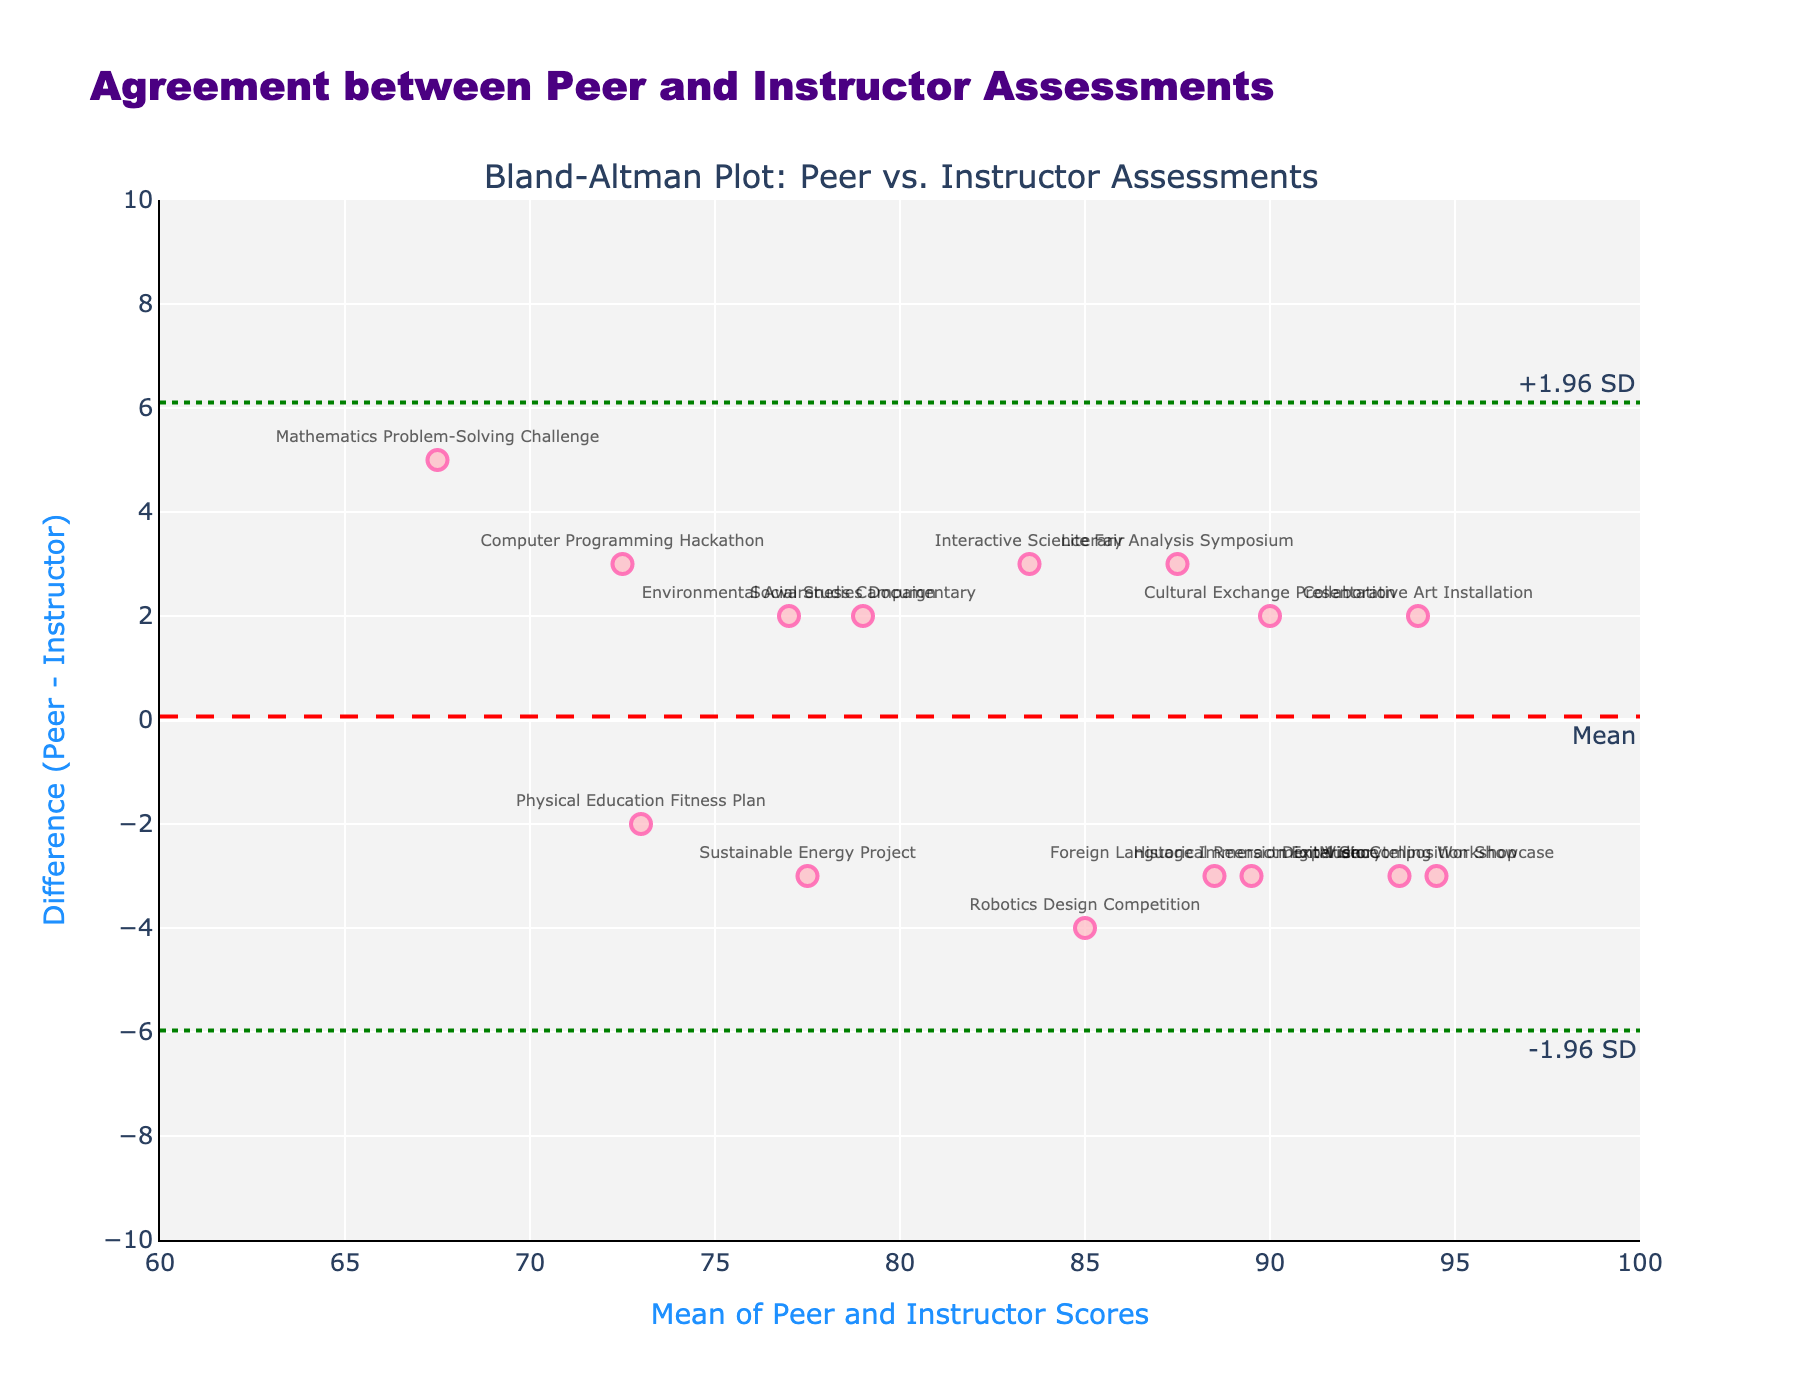What does the title of the plot tell us? The title "Agreement between Peer and Instructor Assessments" indicates that the plot is analyzing the level of agreement between scores given by peers and those given by instructors for group project evaluations.
Answer: Agreement between Peer and Instructor Assessments How many data points are represented in the plot? Each project has a corresponding data point in the plot. Since the dataset lists 15 projects, there are 15 data points.
Answer: 15 What are the units on the x-axis and y-axis, and what do they represent? The x-axis represents the mean of the Peer and Instructor Scores, ranging from 60 to 100 with ticks at every 5-unit interval. The y-axis represents the difference between the Peer and Instructor Scores (Peer - Instructor), ranging from -10 to 10 with ticks at every 2-unit interval.
Answer: x-axis units: Mean of Scores (60-100), y-axis units: Difference (-10 to 10) What is the mean difference between peer and instructor scores, and how is it visually represented on the plot? The mean difference is represented by a red dashed line on the plot. It indicates the average of the differences between peer and instructor scores.
Answer: Red dashed line Identify the project associated with the highest positive difference between peer and instructor scores. The project "Mathematics Problem-Solving Challenge" shows the highest positive difference on the plot, indicating peers scored it higher than the instructor.
Answer: Mathematics Problem-Solving Challenge Which projects fall outside the limits of agreement (±1.96 SD)? Projects that lie outside the green dotted lines on the plot fall outside the limits of agreement. Observing the plot, "Mathematics Problem-Solving Challenge" and "Collaborative Art Installation" exceed the limits.
Answer: Mathematics Problem-Solving Challenge, Collaborative Art Installation Calculate the mean score for the project "Music Composition Showcase" based on the x-axis. Using the x-axis mean of Peer and Instructor Scores for "Music Composition Showcase" (94.5), and knowing Peer was 93 and Instructor was 96, the mean is (93+96)/2.
Answer: 94.5 Compare the average peer score to the average instructor score across all projects. First, sum all Peer Scores and Instructor Scores, then divide by the number of projects. Peer: (85+92+78+88+70+95+83+91+76+89+72+93+80+87+74)/15 = 83.13; Instructor: (82+95+76+91+65+93+87+89+79+86+74+96+78+90+71)/15 = 83.00. Compare the averages.
Answer: Peer: 83.13, Instructor: 83.00 What conclusion can you draw about the overall agreement between peer and instructor scores based on the plot? Considering most data points are close to the mean difference and within the limits of agreement, the overall agreement between peer and instructor scores appears to be high with only a few exceptions.
Answer: High agreement Calculate the standard deviation of the difference between peer and instructor scores. Use the differences to calculate the standard deviation: diff = (3, -3, 2, -3, 5, 2, -4, 2, -3, 3, -2, -3, 2, -3, 3). σ = √Σ(diff - mean)^2 / (n-1). Find mean diff, then σ.
Answer: ~2.97 